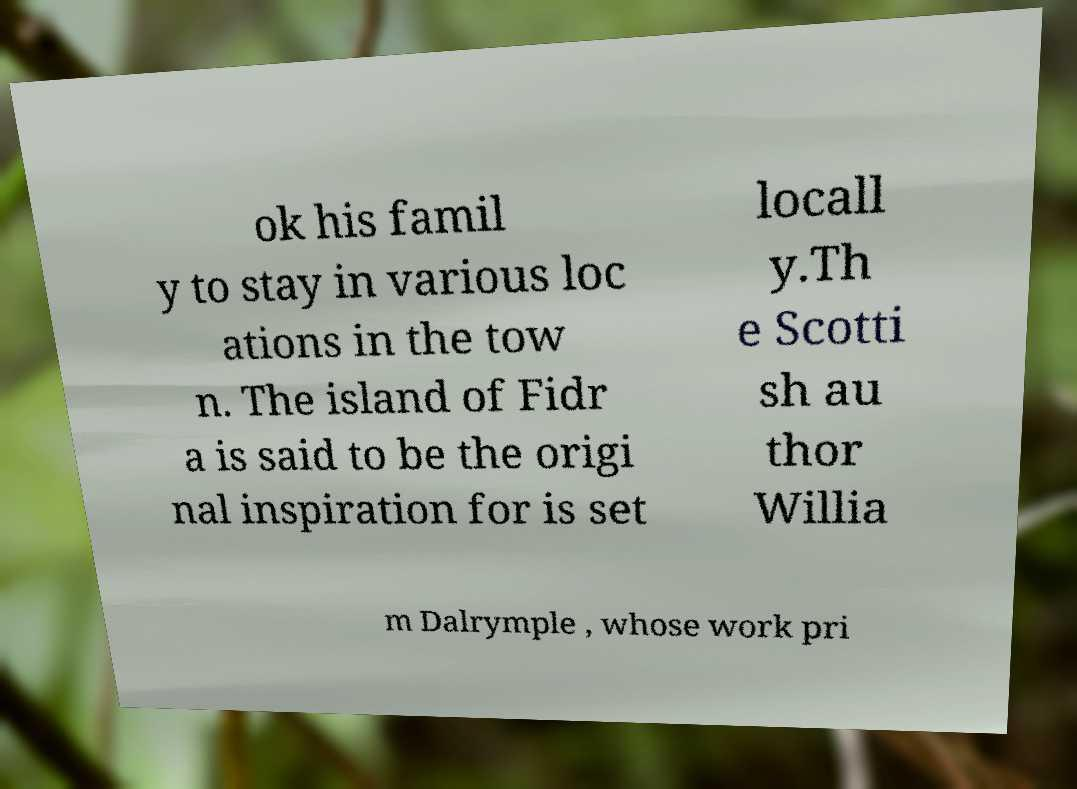There's text embedded in this image that I need extracted. Can you transcribe it verbatim? ok his famil y to stay in various loc ations in the tow n. The island of Fidr a is said to be the origi nal inspiration for is set locall y.Th e Scotti sh au thor Willia m Dalrymple , whose work pri 